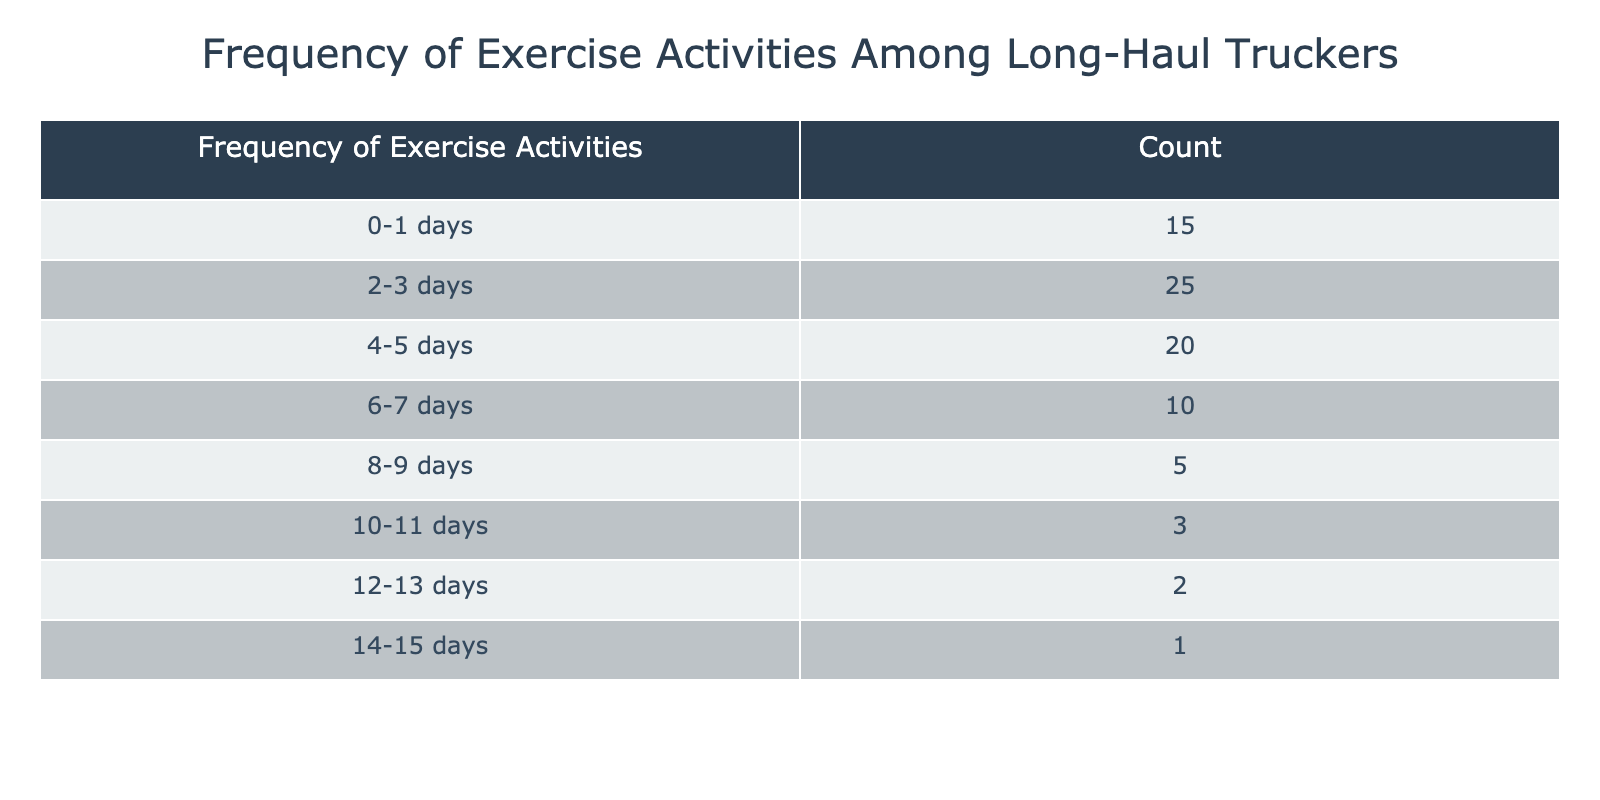What is the total number of truckers who exercised 0-1 days in a month? The table indicates that 15 truckers exercised for 0-1 days. Therefore, the total number of truckers in this category is directly given in the table.
Answer: 15 What is the count of truckers who exercised 4-5 days in a month? According to the table, the count of truckers who exercised for 4-5 days is listed as 20. Hence, the answer can be obtained by looking directly at the relevant row in the table.
Answer: 20 How many truckers exercised for more than 3 days in a month? To find out how many truckers exercised for more than 3 days, we add the counts for the ranges 4-5 days, 6-7 days, 8-9 days, 10-11 days, 12-13 days, and 14-15 days: 20 + 10 + 5 + 3 + 2 + 1 = 41. Thus, there are 41 truckers who exercised for more than 3 days.
Answer: 41 Is it true that more truckers exercised for 2-3 days than for 6-7 days? By referring to the table, 25 truckers exercised for 2-3 days, while only 10 exercised for 6-7 days. Therefore, it is true that more truckers exercised for 2-3 days than for 6-7 days.
Answer: Yes What is the average number of days truckers exercised in a month? To calculate the average, we first find the total count: (15 * 0.5) + (25 * 2.5) + (20 * 4.5) + (10 * 6.5) + (5 * 8.5) + (3 * 10.5) + (2 * 12.5) + (1 * 14.5). This equals 7.5 + 62.5 + 90 + 65 + 42.5 + 31.5 + 25 + 14.5 = 334. The total number of truckers is 81. Thus, the average is 334/81 ≈ 4.12 days.
Answer: Approximately 4.12 days How many more truckers exercised for 0-1 days compared to 10-11 days? In the table, there are 15 truckers who exercised for 0-1 days and 3 who exercised for 10-11 days. The difference is calculated as 15 - 3 = 12, meaning that 12 more truckers exercised for 0-1 days.
Answer: 12 What percentage of truckers exercised for 0-3 days? The total number of truckers is 81. The sum of truckers who exercised 0-1 days (15) and 2-3 days (25) is 40. To find the percentage, we calculate (40/81) * 100 ≈ 49.38%. Thus, approximately 49.38% of truckers exercised for 0-3 days in a month.
Answer: Approximately 49.38% What is the ratio of truckers who exercised 8-9 days to those who exercised 10-11 days? From the table, 5 truckers exercised for 8-9 days and 3 exercised for 10-11 days. The ratio is expressed as 5:3, meaning that for every 5 truckers who exercised 8-9 days, there are 3 who exercised 10-11 days.
Answer: 5:3 